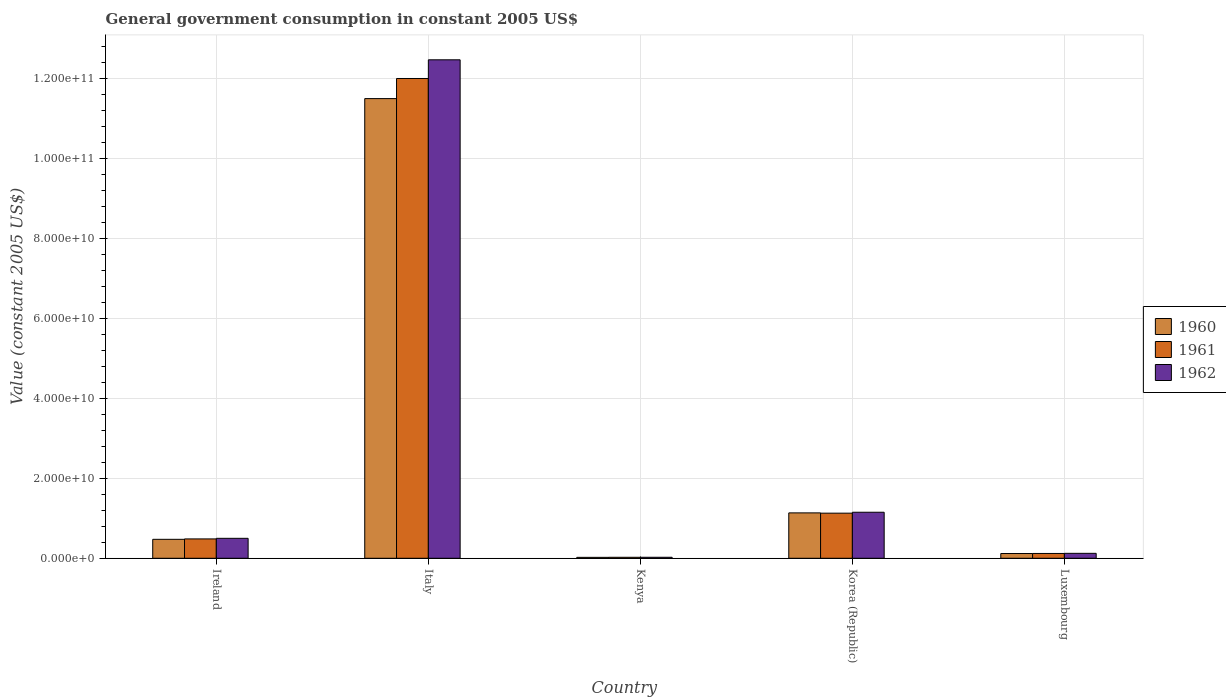How many different coloured bars are there?
Offer a terse response. 3. Are the number of bars per tick equal to the number of legend labels?
Provide a short and direct response. Yes. Are the number of bars on each tick of the X-axis equal?
Make the answer very short. Yes. What is the label of the 5th group of bars from the left?
Your answer should be compact. Luxembourg. In how many cases, is the number of bars for a given country not equal to the number of legend labels?
Give a very brief answer. 0. What is the government conusmption in 1962 in Korea (Republic)?
Ensure brevity in your answer.  1.15e+1. Across all countries, what is the maximum government conusmption in 1962?
Your answer should be compact. 1.25e+11. Across all countries, what is the minimum government conusmption in 1961?
Provide a succinct answer. 2.44e+08. In which country was the government conusmption in 1960 minimum?
Keep it short and to the point. Kenya. What is the total government conusmption in 1960 in the graph?
Give a very brief answer. 1.32e+11. What is the difference between the government conusmption in 1960 in Italy and that in Kenya?
Provide a short and direct response. 1.15e+11. What is the difference between the government conusmption in 1961 in Kenya and the government conusmption in 1960 in Italy?
Provide a succinct answer. -1.15e+11. What is the average government conusmption in 1961 per country?
Ensure brevity in your answer.  2.75e+1. What is the difference between the government conusmption of/in 1960 and government conusmption of/in 1962 in Kenya?
Your response must be concise. -2.21e+07. What is the ratio of the government conusmption in 1962 in Kenya to that in Korea (Republic)?
Your answer should be very brief. 0.02. Is the government conusmption in 1962 in Ireland less than that in Kenya?
Provide a short and direct response. No. Is the difference between the government conusmption in 1960 in Italy and Luxembourg greater than the difference between the government conusmption in 1962 in Italy and Luxembourg?
Offer a terse response. No. What is the difference between the highest and the second highest government conusmption in 1961?
Offer a terse response. 1.15e+11. What is the difference between the highest and the lowest government conusmption in 1961?
Your answer should be compact. 1.20e+11. What does the 3rd bar from the left in Korea (Republic) represents?
Give a very brief answer. 1962. What does the 1st bar from the right in Italy represents?
Offer a very short reply. 1962. What is the difference between two consecutive major ticks on the Y-axis?
Your response must be concise. 2.00e+1. Does the graph contain any zero values?
Offer a very short reply. No. Does the graph contain grids?
Your answer should be compact. Yes. How many legend labels are there?
Offer a very short reply. 3. How are the legend labels stacked?
Your answer should be very brief. Vertical. What is the title of the graph?
Ensure brevity in your answer.  General government consumption in constant 2005 US$. Does "1970" appear as one of the legend labels in the graph?
Provide a succinct answer. No. What is the label or title of the Y-axis?
Your response must be concise. Value (constant 2005 US$). What is the Value (constant 2005 US$) of 1960 in Ireland?
Offer a very short reply. 4.74e+09. What is the Value (constant 2005 US$) of 1961 in Ireland?
Offer a very short reply. 4.84e+09. What is the Value (constant 2005 US$) in 1962 in Ireland?
Provide a succinct answer. 4.99e+09. What is the Value (constant 2005 US$) in 1960 in Italy?
Provide a succinct answer. 1.15e+11. What is the Value (constant 2005 US$) of 1961 in Italy?
Offer a very short reply. 1.20e+11. What is the Value (constant 2005 US$) of 1962 in Italy?
Provide a short and direct response. 1.25e+11. What is the Value (constant 2005 US$) of 1960 in Kenya?
Ensure brevity in your answer.  2.28e+08. What is the Value (constant 2005 US$) in 1961 in Kenya?
Offer a very short reply. 2.44e+08. What is the Value (constant 2005 US$) in 1962 in Kenya?
Offer a terse response. 2.50e+08. What is the Value (constant 2005 US$) of 1960 in Korea (Republic)?
Give a very brief answer. 1.13e+1. What is the Value (constant 2005 US$) of 1961 in Korea (Republic)?
Provide a short and direct response. 1.13e+1. What is the Value (constant 2005 US$) of 1962 in Korea (Republic)?
Give a very brief answer. 1.15e+1. What is the Value (constant 2005 US$) in 1960 in Luxembourg?
Your answer should be compact. 1.19e+09. What is the Value (constant 2005 US$) in 1961 in Luxembourg?
Your answer should be compact. 1.20e+09. What is the Value (constant 2005 US$) of 1962 in Luxembourg?
Provide a short and direct response. 1.23e+09. Across all countries, what is the maximum Value (constant 2005 US$) in 1960?
Your answer should be compact. 1.15e+11. Across all countries, what is the maximum Value (constant 2005 US$) in 1961?
Your response must be concise. 1.20e+11. Across all countries, what is the maximum Value (constant 2005 US$) in 1962?
Give a very brief answer. 1.25e+11. Across all countries, what is the minimum Value (constant 2005 US$) of 1960?
Provide a succinct answer. 2.28e+08. Across all countries, what is the minimum Value (constant 2005 US$) of 1961?
Ensure brevity in your answer.  2.44e+08. Across all countries, what is the minimum Value (constant 2005 US$) of 1962?
Offer a very short reply. 2.50e+08. What is the total Value (constant 2005 US$) in 1960 in the graph?
Provide a succinct answer. 1.32e+11. What is the total Value (constant 2005 US$) in 1961 in the graph?
Ensure brevity in your answer.  1.38e+11. What is the total Value (constant 2005 US$) in 1962 in the graph?
Keep it short and to the point. 1.43e+11. What is the difference between the Value (constant 2005 US$) of 1960 in Ireland and that in Italy?
Give a very brief answer. -1.10e+11. What is the difference between the Value (constant 2005 US$) in 1961 in Ireland and that in Italy?
Offer a very short reply. -1.15e+11. What is the difference between the Value (constant 2005 US$) in 1962 in Ireland and that in Italy?
Your answer should be compact. -1.20e+11. What is the difference between the Value (constant 2005 US$) in 1960 in Ireland and that in Kenya?
Keep it short and to the point. 4.51e+09. What is the difference between the Value (constant 2005 US$) of 1961 in Ireland and that in Kenya?
Your answer should be very brief. 4.60e+09. What is the difference between the Value (constant 2005 US$) in 1962 in Ireland and that in Kenya?
Your response must be concise. 4.74e+09. What is the difference between the Value (constant 2005 US$) of 1960 in Ireland and that in Korea (Republic)?
Ensure brevity in your answer.  -6.61e+09. What is the difference between the Value (constant 2005 US$) in 1961 in Ireland and that in Korea (Republic)?
Provide a short and direct response. -6.44e+09. What is the difference between the Value (constant 2005 US$) of 1962 in Ireland and that in Korea (Republic)?
Make the answer very short. -6.52e+09. What is the difference between the Value (constant 2005 US$) of 1960 in Ireland and that in Luxembourg?
Offer a terse response. 3.55e+09. What is the difference between the Value (constant 2005 US$) of 1961 in Ireland and that in Luxembourg?
Make the answer very short. 3.64e+09. What is the difference between the Value (constant 2005 US$) in 1962 in Ireland and that in Luxembourg?
Ensure brevity in your answer.  3.76e+09. What is the difference between the Value (constant 2005 US$) in 1960 in Italy and that in Kenya?
Provide a short and direct response. 1.15e+11. What is the difference between the Value (constant 2005 US$) of 1961 in Italy and that in Kenya?
Your answer should be very brief. 1.20e+11. What is the difference between the Value (constant 2005 US$) in 1962 in Italy and that in Kenya?
Your response must be concise. 1.24e+11. What is the difference between the Value (constant 2005 US$) of 1960 in Italy and that in Korea (Republic)?
Your answer should be very brief. 1.04e+11. What is the difference between the Value (constant 2005 US$) of 1961 in Italy and that in Korea (Republic)?
Ensure brevity in your answer.  1.09e+11. What is the difference between the Value (constant 2005 US$) in 1962 in Italy and that in Korea (Republic)?
Your answer should be very brief. 1.13e+11. What is the difference between the Value (constant 2005 US$) of 1960 in Italy and that in Luxembourg?
Give a very brief answer. 1.14e+11. What is the difference between the Value (constant 2005 US$) of 1961 in Italy and that in Luxembourg?
Offer a terse response. 1.19e+11. What is the difference between the Value (constant 2005 US$) of 1962 in Italy and that in Luxembourg?
Your answer should be compact. 1.23e+11. What is the difference between the Value (constant 2005 US$) in 1960 in Kenya and that in Korea (Republic)?
Keep it short and to the point. -1.11e+1. What is the difference between the Value (constant 2005 US$) of 1961 in Kenya and that in Korea (Republic)?
Offer a terse response. -1.10e+1. What is the difference between the Value (constant 2005 US$) in 1962 in Kenya and that in Korea (Republic)?
Your response must be concise. -1.13e+1. What is the difference between the Value (constant 2005 US$) in 1960 in Kenya and that in Luxembourg?
Offer a very short reply. -9.60e+08. What is the difference between the Value (constant 2005 US$) of 1961 in Kenya and that in Luxembourg?
Your answer should be compact. -9.60e+08. What is the difference between the Value (constant 2005 US$) of 1962 in Kenya and that in Luxembourg?
Give a very brief answer. -9.82e+08. What is the difference between the Value (constant 2005 US$) of 1960 in Korea (Republic) and that in Luxembourg?
Ensure brevity in your answer.  1.02e+1. What is the difference between the Value (constant 2005 US$) in 1961 in Korea (Republic) and that in Luxembourg?
Provide a short and direct response. 1.01e+1. What is the difference between the Value (constant 2005 US$) of 1962 in Korea (Republic) and that in Luxembourg?
Ensure brevity in your answer.  1.03e+1. What is the difference between the Value (constant 2005 US$) in 1960 in Ireland and the Value (constant 2005 US$) in 1961 in Italy?
Offer a very short reply. -1.15e+11. What is the difference between the Value (constant 2005 US$) in 1960 in Ireland and the Value (constant 2005 US$) in 1962 in Italy?
Your answer should be compact. -1.20e+11. What is the difference between the Value (constant 2005 US$) of 1961 in Ireland and the Value (constant 2005 US$) of 1962 in Italy?
Offer a terse response. -1.20e+11. What is the difference between the Value (constant 2005 US$) of 1960 in Ireland and the Value (constant 2005 US$) of 1961 in Kenya?
Your response must be concise. 4.50e+09. What is the difference between the Value (constant 2005 US$) in 1960 in Ireland and the Value (constant 2005 US$) in 1962 in Kenya?
Offer a very short reply. 4.49e+09. What is the difference between the Value (constant 2005 US$) in 1961 in Ireland and the Value (constant 2005 US$) in 1962 in Kenya?
Ensure brevity in your answer.  4.59e+09. What is the difference between the Value (constant 2005 US$) in 1960 in Ireland and the Value (constant 2005 US$) in 1961 in Korea (Republic)?
Provide a succinct answer. -6.54e+09. What is the difference between the Value (constant 2005 US$) of 1960 in Ireland and the Value (constant 2005 US$) of 1962 in Korea (Republic)?
Your response must be concise. -6.77e+09. What is the difference between the Value (constant 2005 US$) of 1961 in Ireland and the Value (constant 2005 US$) of 1962 in Korea (Republic)?
Make the answer very short. -6.67e+09. What is the difference between the Value (constant 2005 US$) in 1960 in Ireland and the Value (constant 2005 US$) in 1961 in Luxembourg?
Your answer should be compact. 3.54e+09. What is the difference between the Value (constant 2005 US$) in 1960 in Ireland and the Value (constant 2005 US$) in 1962 in Luxembourg?
Make the answer very short. 3.51e+09. What is the difference between the Value (constant 2005 US$) in 1961 in Ireland and the Value (constant 2005 US$) in 1962 in Luxembourg?
Provide a short and direct response. 3.61e+09. What is the difference between the Value (constant 2005 US$) of 1960 in Italy and the Value (constant 2005 US$) of 1961 in Kenya?
Your response must be concise. 1.15e+11. What is the difference between the Value (constant 2005 US$) of 1960 in Italy and the Value (constant 2005 US$) of 1962 in Kenya?
Provide a succinct answer. 1.15e+11. What is the difference between the Value (constant 2005 US$) in 1961 in Italy and the Value (constant 2005 US$) in 1962 in Kenya?
Your answer should be compact. 1.20e+11. What is the difference between the Value (constant 2005 US$) in 1960 in Italy and the Value (constant 2005 US$) in 1961 in Korea (Republic)?
Your answer should be very brief. 1.04e+11. What is the difference between the Value (constant 2005 US$) in 1960 in Italy and the Value (constant 2005 US$) in 1962 in Korea (Republic)?
Your answer should be compact. 1.03e+11. What is the difference between the Value (constant 2005 US$) in 1961 in Italy and the Value (constant 2005 US$) in 1962 in Korea (Republic)?
Your response must be concise. 1.08e+11. What is the difference between the Value (constant 2005 US$) of 1960 in Italy and the Value (constant 2005 US$) of 1961 in Luxembourg?
Offer a very short reply. 1.14e+11. What is the difference between the Value (constant 2005 US$) of 1960 in Italy and the Value (constant 2005 US$) of 1962 in Luxembourg?
Keep it short and to the point. 1.14e+11. What is the difference between the Value (constant 2005 US$) of 1961 in Italy and the Value (constant 2005 US$) of 1962 in Luxembourg?
Give a very brief answer. 1.19e+11. What is the difference between the Value (constant 2005 US$) of 1960 in Kenya and the Value (constant 2005 US$) of 1961 in Korea (Republic)?
Offer a very short reply. -1.11e+1. What is the difference between the Value (constant 2005 US$) of 1960 in Kenya and the Value (constant 2005 US$) of 1962 in Korea (Republic)?
Offer a very short reply. -1.13e+1. What is the difference between the Value (constant 2005 US$) in 1961 in Kenya and the Value (constant 2005 US$) in 1962 in Korea (Republic)?
Keep it short and to the point. -1.13e+1. What is the difference between the Value (constant 2005 US$) in 1960 in Kenya and the Value (constant 2005 US$) in 1961 in Luxembourg?
Your response must be concise. -9.75e+08. What is the difference between the Value (constant 2005 US$) of 1960 in Kenya and the Value (constant 2005 US$) of 1962 in Luxembourg?
Keep it short and to the point. -1.00e+09. What is the difference between the Value (constant 2005 US$) in 1961 in Kenya and the Value (constant 2005 US$) in 1962 in Luxembourg?
Give a very brief answer. -9.89e+08. What is the difference between the Value (constant 2005 US$) of 1960 in Korea (Republic) and the Value (constant 2005 US$) of 1961 in Luxembourg?
Provide a short and direct response. 1.01e+1. What is the difference between the Value (constant 2005 US$) of 1960 in Korea (Republic) and the Value (constant 2005 US$) of 1962 in Luxembourg?
Provide a succinct answer. 1.01e+1. What is the difference between the Value (constant 2005 US$) in 1961 in Korea (Republic) and the Value (constant 2005 US$) in 1962 in Luxembourg?
Your answer should be compact. 1.00e+1. What is the average Value (constant 2005 US$) of 1960 per country?
Your answer should be compact. 2.65e+1. What is the average Value (constant 2005 US$) of 1961 per country?
Provide a short and direct response. 2.75e+1. What is the average Value (constant 2005 US$) of 1962 per country?
Your answer should be compact. 2.85e+1. What is the difference between the Value (constant 2005 US$) in 1960 and Value (constant 2005 US$) in 1961 in Ireland?
Provide a succinct answer. -9.93e+07. What is the difference between the Value (constant 2005 US$) of 1960 and Value (constant 2005 US$) of 1962 in Ireland?
Provide a succinct answer. -2.51e+08. What is the difference between the Value (constant 2005 US$) of 1961 and Value (constant 2005 US$) of 1962 in Ireland?
Make the answer very short. -1.51e+08. What is the difference between the Value (constant 2005 US$) of 1960 and Value (constant 2005 US$) of 1961 in Italy?
Ensure brevity in your answer.  -5.03e+09. What is the difference between the Value (constant 2005 US$) in 1960 and Value (constant 2005 US$) in 1962 in Italy?
Offer a terse response. -9.70e+09. What is the difference between the Value (constant 2005 US$) of 1961 and Value (constant 2005 US$) of 1962 in Italy?
Ensure brevity in your answer.  -4.67e+09. What is the difference between the Value (constant 2005 US$) of 1960 and Value (constant 2005 US$) of 1961 in Kenya?
Your answer should be very brief. -1.55e+07. What is the difference between the Value (constant 2005 US$) of 1960 and Value (constant 2005 US$) of 1962 in Kenya?
Make the answer very short. -2.21e+07. What is the difference between the Value (constant 2005 US$) in 1961 and Value (constant 2005 US$) in 1962 in Kenya?
Provide a short and direct response. -6.66e+06. What is the difference between the Value (constant 2005 US$) in 1960 and Value (constant 2005 US$) in 1961 in Korea (Republic)?
Ensure brevity in your answer.  7.08e+07. What is the difference between the Value (constant 2005 US$) in 1960 and Value (constant 2005 US$) in 1962 in Korea (Republic)?
Keep it short and to the point. -1.63e+08. What is the difference between the Value (constant 2005 US$) in 1961 and Value (constant 2005 US$) in 1962 in Korea (Republic)?
Offer a terse response. -2.34e+08. What is the difference between the Value (constant 2005 US$) in 1960 and Value (constant 2005 US$) in 1961 in Luxembourg?
Ensure brevity in your answer.  -1.55e+07. What is the difference between the Value (constant 2005 US$) in 1960 and Value (constant 2005 US$) in 1962 in Luxembourg?
Your answer should be compact. -4.43e+07. What is the difference between the Value (constant 2005 US$) in 1961 and Value (constant 2005 US$) in 1962 in Luxembourg?
Provide a short and direct response. -2.88e+07. What is the ratio of the Value (constant 2005 US$) in 1960 in Ireland to that in Italy?
Your response must be concise. 0.04. What is the ratio of the Value (constant 2005 US$) in 1961 in Ireland to that in Italy?
Your answer should be very brief. 0.04. What is the ratio of the Value (constant 2005 US$) of 1960 in Ireland to that in Kenya?
Your answer should be compact. 20.76. What is the ratio of the Value (constant 2005 US$) in 1961 in Ireland to that in Kenya?
Your response must be concise. 19.85. What is the ratio of the Value (constant 2005 US$) of 1962 in Ireland to that in Kenya?
Offer a very short reply. 19.93. What is the ratio of the Value (constant 2005 US$) in 1960 in Ireland to that in Korea (Republic)?
Make the answer very short. 0.42. What is the ratio of the Value (constant 2005 US$) in 1961 in Ireland to that in Korea (Republic)?
Your answer should be compact. 0.43. What is the ratio of the Value (constant 2005 US$) in 1962 in Ireland to that in Korea (Republic)?
Provide a succinct answer. 0.43. What is the ratio of the Value (constant 2005 US$) in 1960 in Ireland to that in Luxembourg?
Provide a short and direct response. 3.99. What is the ratio of the Value (constant 2005 US$) in 1961 in Ireland to that in Luxembourg?
Keep it short and to the point. 4.02. What is the ratio of the Value (constant 2005 US$) of 1962 in Ireland to that in Luxembourg?
Provide a succinct answer. 4.05. What is the ratio of the Value (constant 2005 US$) in 1960 in Italy to that in Kenya?
Offer a very short reply. 503.61. What is the ratio of the Value (constant 2005 US$) in 1961 in Italy to that in Kenya?
Your response must be concise. 492.25. What is the ratio of the Value (constant 2005 US$) in 1962 in Italy to that in Kenya?
Make the answer very short. 497.82. What is the ratio of the Value (constant 2005 US$) in 1960 in Italy to that in Korea (Republic)?
Your response must be concise. 10.13. What is the ratio of the Value (constant 2005 US$) of 1961 in Italy to that in Korea (Republic)?
Provide a short and direct response. 10.64. What is the ratio of the Value (constant 2005 US$) in 1962 in Italy to that in Korea (Republic)?
Ensure brevity in your answer.  10.83. What is the ratio of the Value (constant 2005 US$) of 1960 in Italy to that in Luxembourg?
Offer a very short reply. 96.74. What is the ratio of the Value (constant 2005 US$) in 1961 in Italy to that in Luxembourg?
Make the answer very short. 99.68. What is the ratio of the Value (constant 2005 US$) in 1962 in Italy to that in Luxembourg?
Provide a succinct answer. 101.14. What is the ratio of the Value (constant 2005 US$) in 1960 in Kenya to that in Korea (Republic)?
Make the answer very short. 0.02. What is the ratio of the Value (constant 2005 US$) of 1961 in Kenya to that in Korea (Republic)?
Your response must be concise. 0.02. What is the ratio of the Value (constant 2005 US$) in 1962 in Kenya to that in Korea (Republic)?
Keep it short and to the point. 0.02. What is the ratio of the Value (constant 2005 US$) of 1960 in Kenya to that in Luxembourg?
Make the answer very short. 0.19. What is the ratio of the Value (constant 2005 US$) in 1961 in Kenya to that in Luxembourg?
Your answer should be very brief. 0.2. What is the ratio of the Value (constant 2005 US$) of 1962 in Kenya to that in Luxembourg?
Offer a very short reply. 0.2. What is the ratio of the Value (constant 2005 US$) of 1960 in Korea (Republic) to that in Luxembourg?
Your response must be concise. 9.55. What is the ratio of the Value (constant 2005 US$) in 1961 in Korea (Republic) to that in Luxembourg?
Ensure brevity in your answer.  9.37. What is the ratio of the Value (constant 2005 US$) of 1962 in Korea (Republic) to that in Luxembourg?
Your answer should be compact. 9.34. What is the difference between the highest and the second highest Value (constant 2005 US$) in 1960?
Offer a very short reply. 1.04e+11. What is the difference between the highest and the second highest Value (constant 2005 US$) in 1961?
Provide a short and direct response. 1.09e+11. What is the difference between the highest and the second highest Value (constant 2005 US$) of 1962?
Provide a short and direct response. 1.13e+11. What is the difference between the highest and the lowest Value (constant 2005 US$) of 1960?
Offer a terse response. 1.15e+11. What is the difference between the highest and the lowest Value (constant 2005 US$) in 1961?
Provide a succinct answer. 1.20e+11. What is the difference between the highest and the lowest Value (constant 2005 US$) of 1962?
Offer a very short reply. 1.24e+11. 